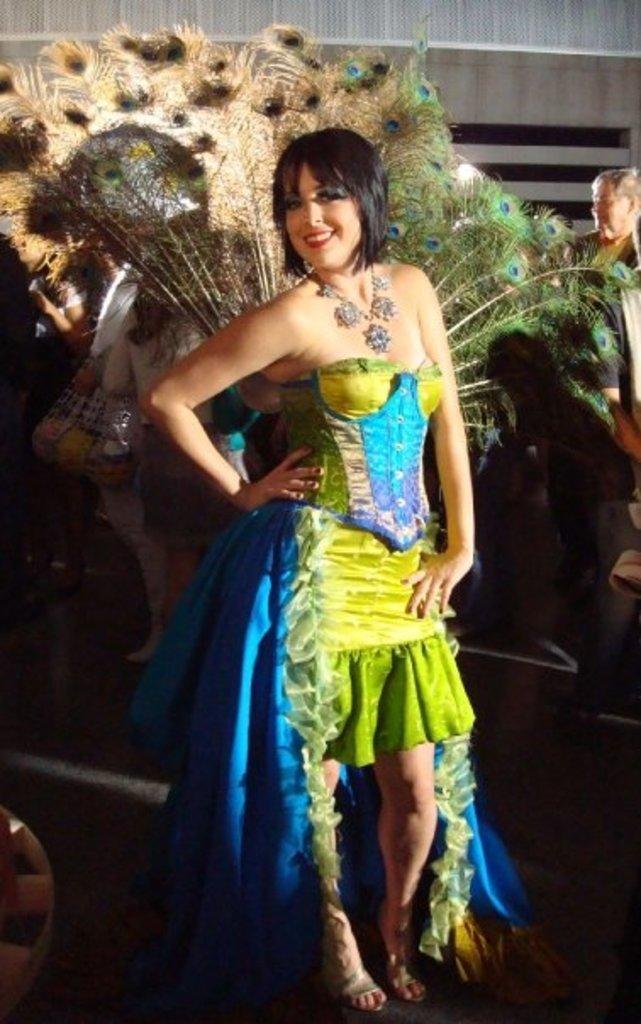In one or two sentences, can you explain what this image depicts? In the center of this picture we can see a woman wearing a dress and some other objects, smiling and standing. In the background we can see the group of people and many other objects. 